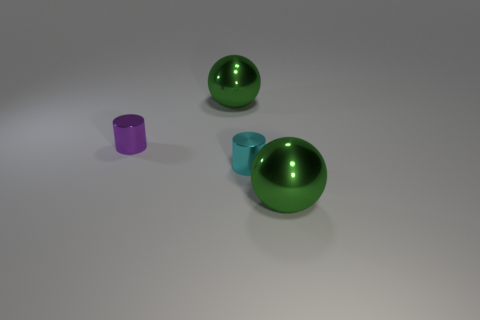Add 1 balls. How many objects exist? 5 Add 2 small shiny cylinders. How many small shiny cylinders are left? 4 Add 2 big green shiny spheres. How many big green shiny spheres exist? 4 Subtract 0 cyan cubes. How many objects are left? 4 Subtract all big metal objects. Subtract all purple metal things. How many objects are left? 1 